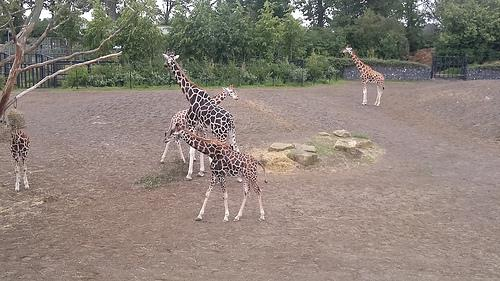Question: when will the giraffes eat?
Choices:
A. Soon.
B. In 2 hrs.
C. Now.
D. Later.
Answer with the letter. Answer: D Question: what are the giraffe doing?
Choices:
A. Walking around.
B. Eating.
C. Standing still.
D. Getting a drink.
Answer with the letter. Answer: A Question: what is the color of the giraffe?
Choices:
A. Orange.
B. White.
C. Brown.
D. Cream.
Answer with the letter. Answer: C Question: who is outside the fence?
Choices:
A. A woman.
B. A family.
C. No one.
D. A man.
Answer with the letter. Answer: C Question: how many giraffe in the fence?
Choices:
A. Twenty.
B. Twelve.
C. Five.
D. Ten.
Answer with the letter. Answer: C Question: what is the ground made of?
Choices:
A. Cement.
B. Soil.
C. Asphalt.
D. Astroturf.
Answer with the letter. Answer: B 